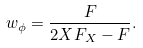Convert formula to latex. <formula><loc_0><loc_0><loc_500><loc_500>w _ { \phi } = \frac { F } { 2 X F _ { X } - F } .</formula> 